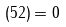<formula> <loc_0><loc_0><loc_500><loc_500>( 5 2 ) = 0</formula> 